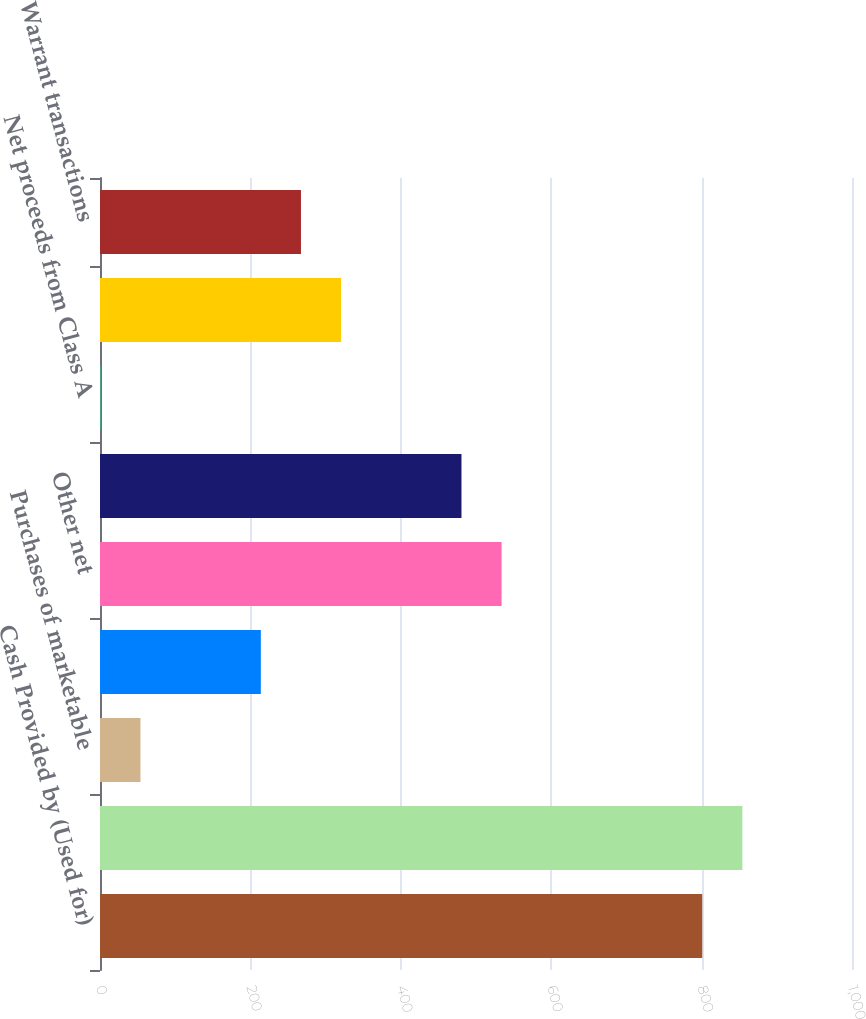Convert chart to OTSL. <chart><loc_0><loc_0><loc_500><loc_500><bar_chart><fcel>Cash Provided by (Used for)<fcel>Additions to property plant<fcel>Purchases of marketable<fcel>Acquisitions net of cash<fcel>Other net<fcel>Net change in debt<fcel>Net proceeds from Class A<fcel>Convertible note hedge<fcel>Warrant transactions<nl><fcel>800.84<fcel>854.2<fcel>53.8<fcel>213.88<fcel>534.04<fcel>480.68<fcel>0.44<fcel>320.6<fcel>267.24<nl></chart> 